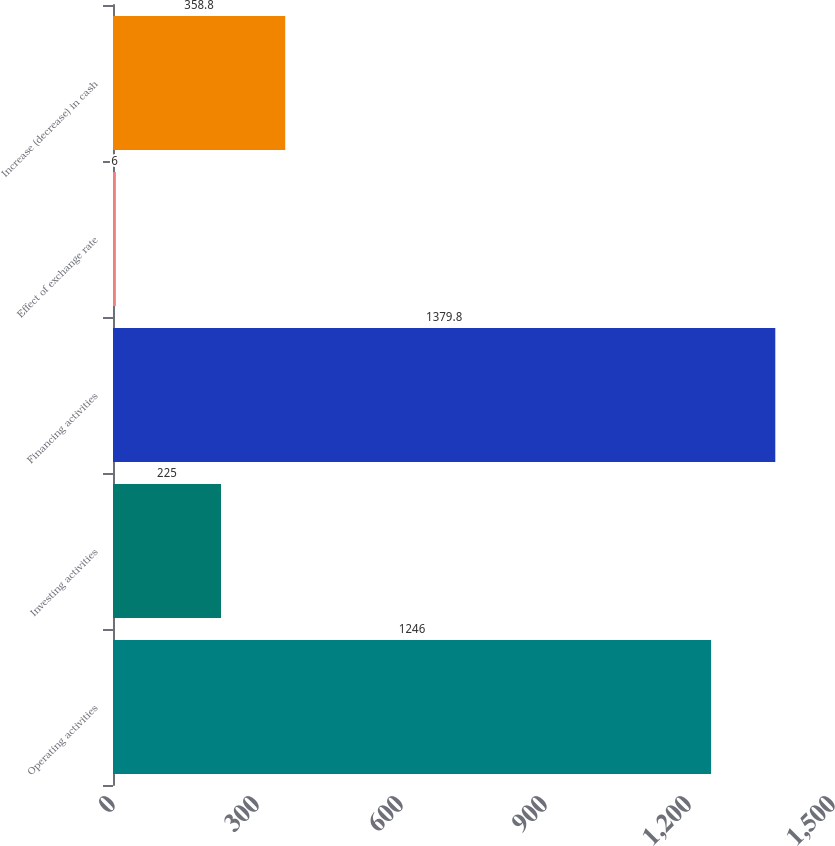Convert chart. <chart><loc_0><loc_0><loc_500><loc_500><bar_chart><fcel>Operating activities<fcel>Investing activities<fcel>Financing activities<fcel>Effect of exchange rate<fcel>Increase (decrease) in cash<nl><fcel>1246<fcel>225<fcel>1379.8<fcel>6<fcel>358.8<nl></chart> 